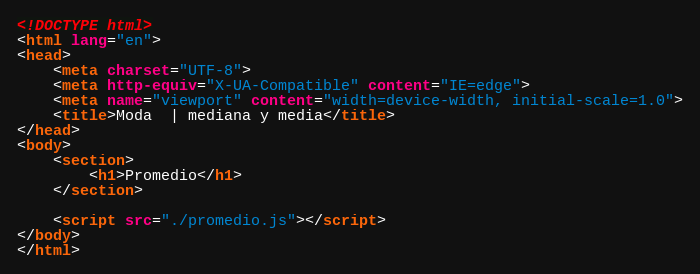<code> <loc_0><loc_0><loc_500><loc_500><_HTML_><!DOCTYPE html>
<html lang="en">
<head>
    <meta charset="UTF-8">
    <meta http-equiv="X-UA-Compatible" content="IE=edge">
    <meta name="viewport" content="width=device-width, initial-scale=1.0">
    <title>Moda  | mediana y media</title>
</head>
<body>
    <section>
        <h1>Promedio</h1>
    </section>

    <script src="./promedio.js"></script>
</body>
</html></code> 